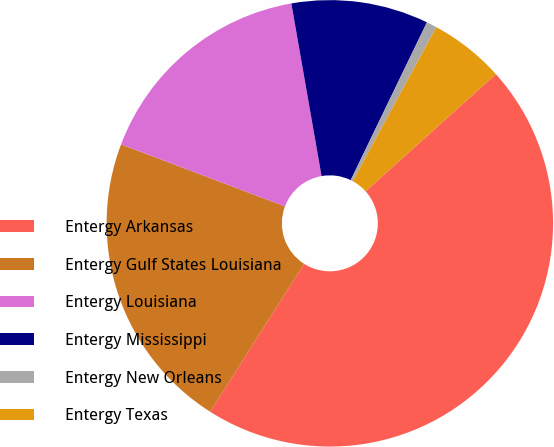Convert chart. <chart><loc_0><loc_0><loc_500><loc_500><pie_chart><fcel>Entergy Arkansas<fcel>Entergy Gulf States Louisiana<fcel>Entergy Louisiana<fcel>Entergy Mississippi<fcel>Entergy New Orleans<fcel>Entergy Texas<nl><fcel>45.66%<fcel>21.74%<fcel>16.49%<fcel>9.92%<fcel>0.75%<fcel>5.44%<nl></chart> 